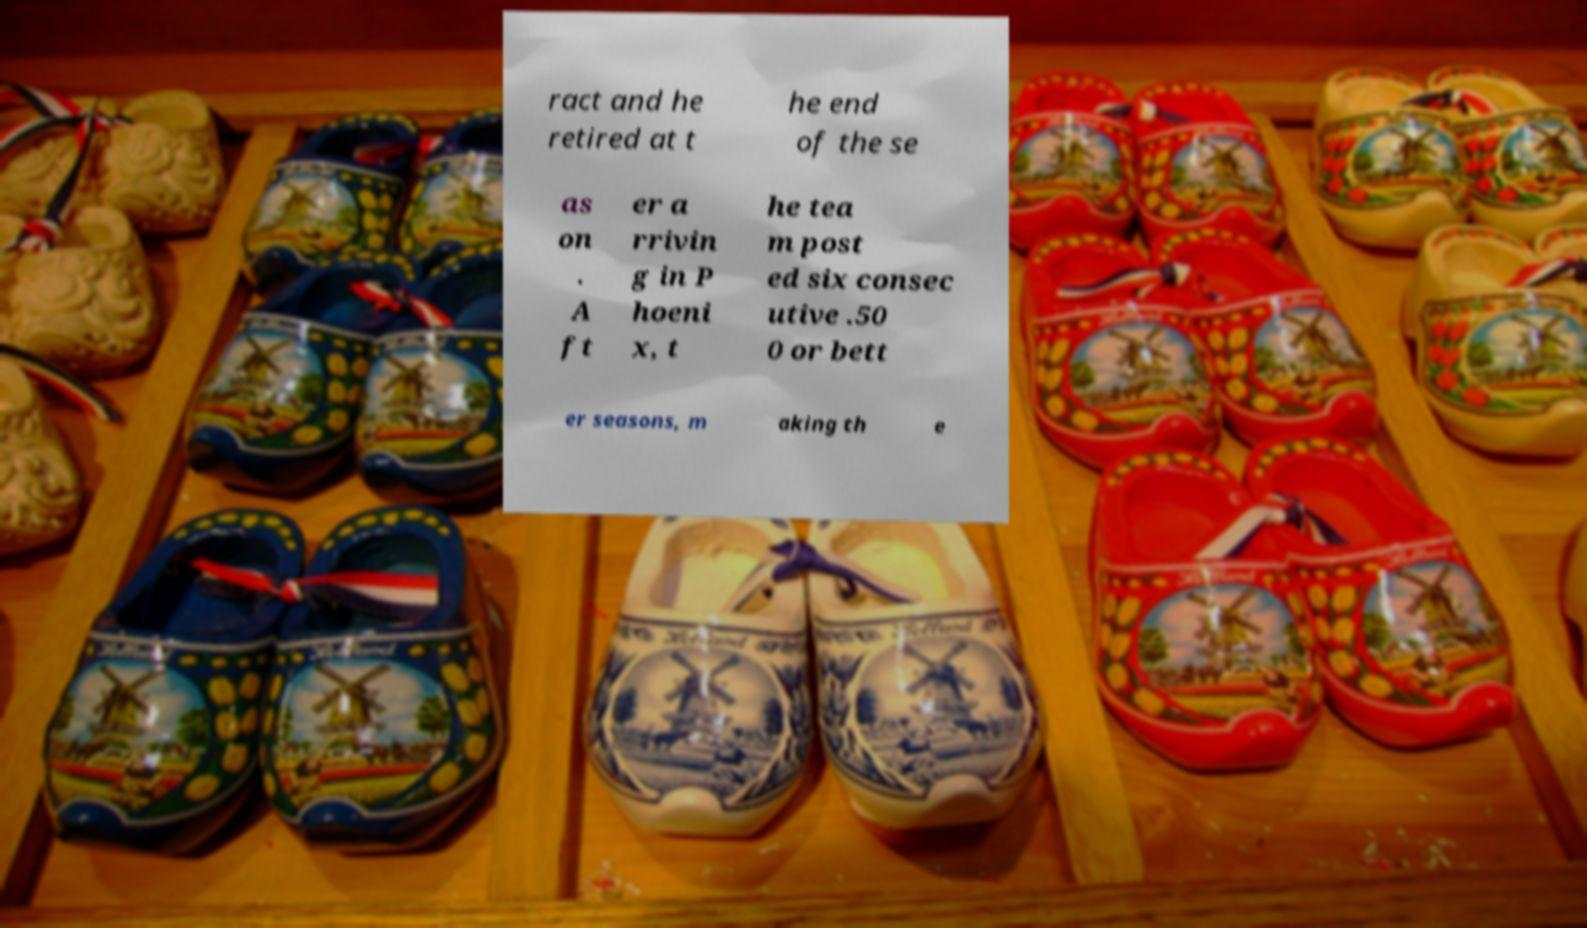Can you read and provide the text displayed in the image?This photo seems to have some interesting text. Can you extract and type it out for me? ract and he retired at t he end of the se as on . A ft er a rrivin g in P hoeni x, t he tea m post ed six consec utive .50 0 or bett er seasons, m aking th e 